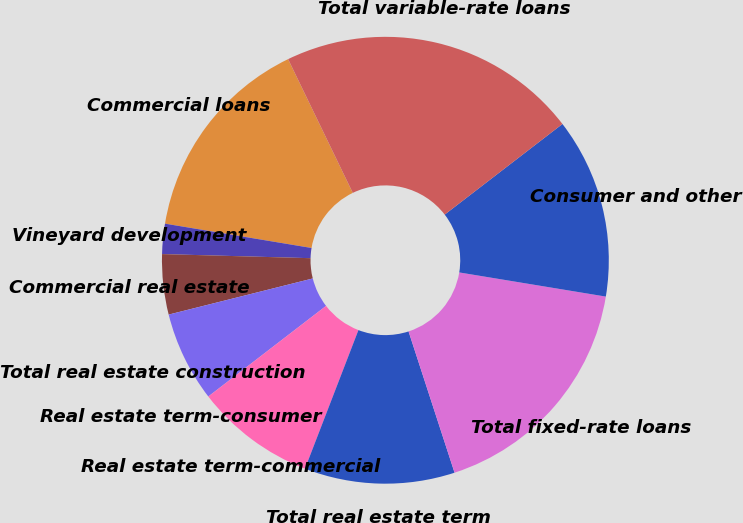<chart> <loc_0><loc_0><loc_500><loc_500><pie_chart><fcel>Commercial loans<fcel>Vineyard development<fcel>Commercial real estate<fcel>Total real estate construction<fcel>Real estate term-consumer<fcel>Real estate term-commercial<fcel>Total real estate term<fcel>Total fixed-rate loans<fcel>Consumer and other<fcel>Total variable-rate loans<nl><fcel>15.21%<fcel>2.18%<fcel>4.35%<fcel>6.52%<fcel>0.01%<fcel>8.7%<fcel>10.87%<fcel>17.39%<fcel>13.04%<fcel>21.73%<nl></chart> 